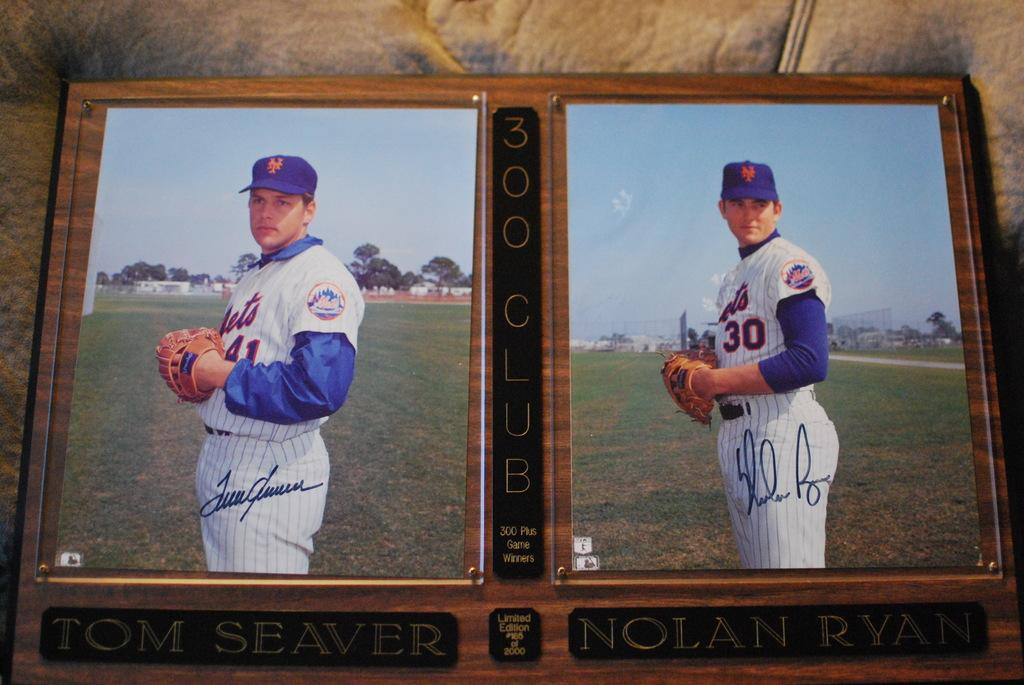<image>
Give a short and clear explanation of the subsequent image. A plaque displays pictures of Nolan Ryan and Tom Seaver as members of the 300-strikeout club. 